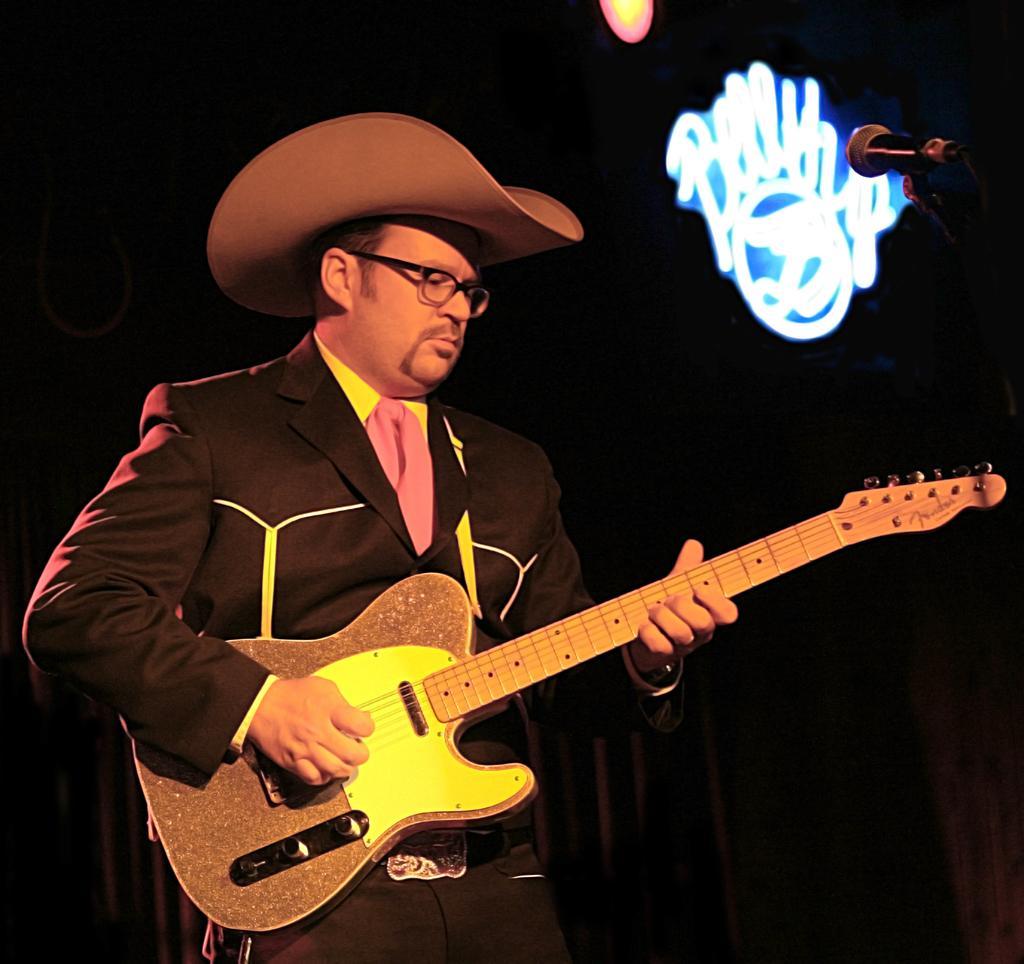Can you describe this image briefly? A man is playing a guitar wearing a hat. 